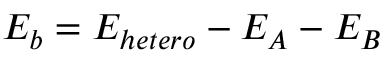<formula> <loc_0><loc_0><loc_500><loc_500>E _ { b } = E _ { h e t e r o } - E _ { A } - E _ { B }</formula> 